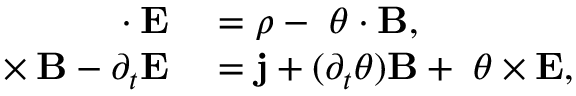<formula> <loc_0><loc_0><loc_500><loc_500>\begin{array} { r l } { \nabla \cdot E } & = \rho - \nabla \theta \cdot B , } \\ { \nabla \times B - \partial _ { t } E } & = j + ( \partial _ { t } \theta ) B + \nabla \theta \times E , } \end{array}</formula> 